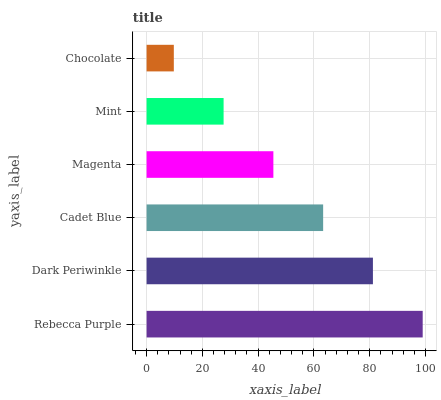Is Chocolate the minimum?
Answer yes or no. Yes. Is Rebecca Purple the maximum?
Answer yes or no. Yes. Is Dark Periwinkle the minimum?
Answer yes or no. No. Is Dark Periwinkle the maximum?
Answer yes or no. No. Is Rebecca Purple greater than Dark Periwinkle?
Answer yes or no. Yes. Is Dark Periwinkle less than Rebecca Purple?
Answer yes or no. Yes. Is Dark Periwinkle greater than Rebecca Purple?
Answer yes or no. No. Is Rebecca Purple less than Dark Periwinkle?
Answer yes or no. No. Is Cadet Blue the high median?
Answer yes or no. Yes. Is Magenta the low median?
Answer yes or no. Yes. Is Rebecca Purple the high median?
Answer yes or no. No. Is Chocolate the low median?
Answer yes or no. No. 